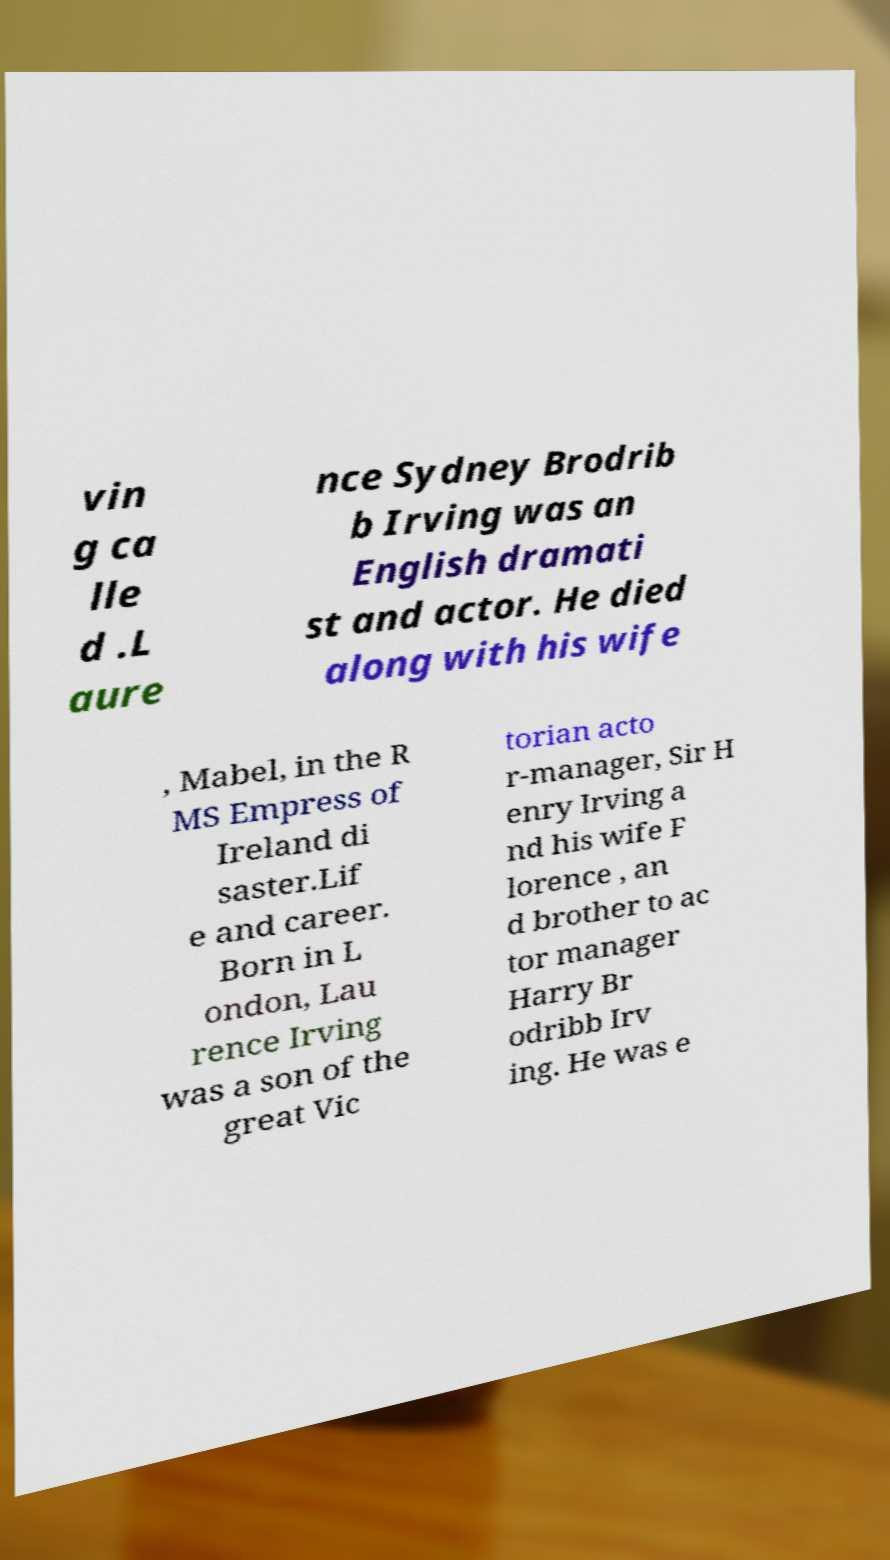Could you extract and type out the text from this image? vin g ca lle d .L aure nce Sydney Brodrib b Irving was an English dramati st and actor. He died along with his wife , Mabel, in the R MS Empress of Ireland di saster.Lif e and career. Born in L ondon, Lau rence Irving was a son of the great Vic torian acto r-manager, Sir H enry Irving a nd his wife F lorence , an d brother to ac tor manager Harry Br odribb Irv ing. He was e 